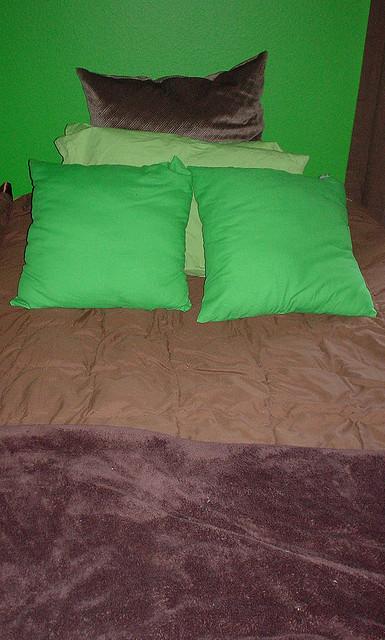How many green pillows?
Be succinct. 3. What color is the bedspread?
Answer briefly. Brown. Is the bed made?
Keep it brief. Yes. Is this bed on the floor?
Answer briefly. Yes. 